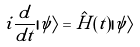Convert formula to latex. <formula><loc_0><loc_0><loc_500><loc_500>i \frac { d } { d t } | \psi \rangle = \hat { H } ( t ) | \psi \rangle</formula> 